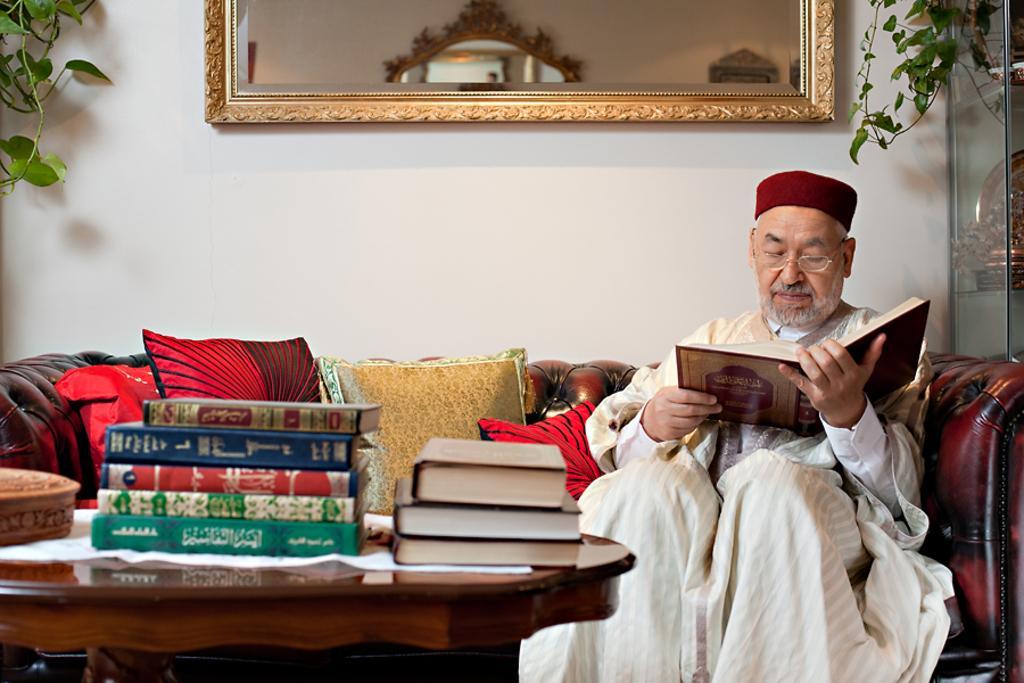Could you give a brief overview of what you see in this image? In this image a person is sitting and holding a book wearing spectacles and cap on his head. He is sitting on sofa having some colourful cushions on it. In Front of him there is a table with some books and bowl is kept on it. At the left top corner there is a plant. In middle top of the image there is a mirror. At the right side top corner there is a plant and a shield in the glass shelf. 